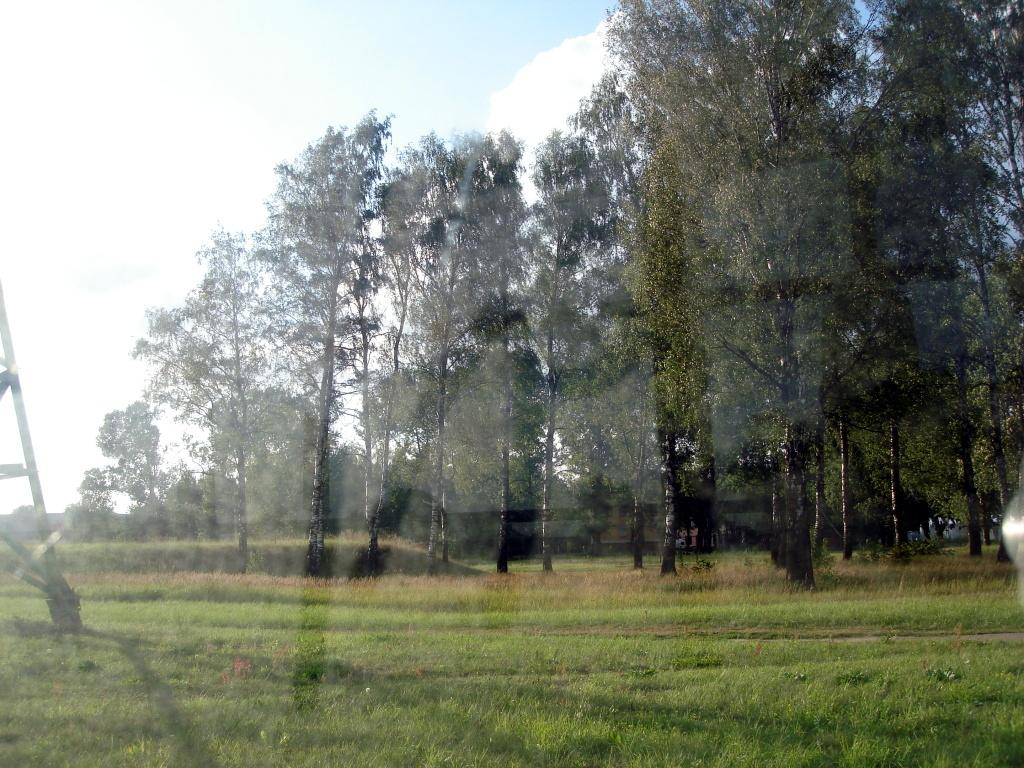What type of vegetation is present in the image? There is grass and trees in the image. What structure can be seen in the image? There is a stand in the image. What type of light can be seen illuminating the wilderness in the image? There is no wilderness or light source present in the image; it features grass, trees, and a stand. 